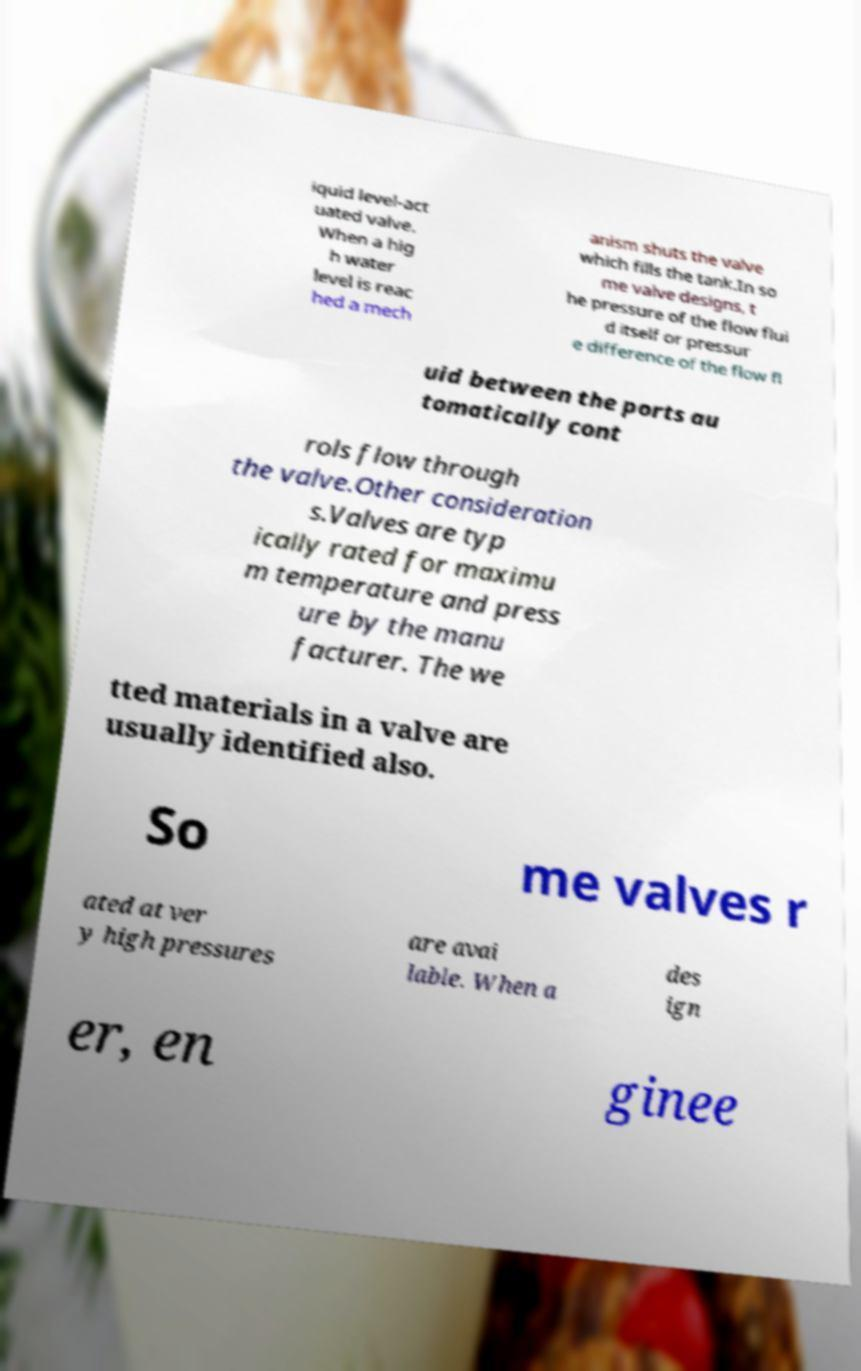Please identify and transcribe the text found in this image. iquid level-act uated valve. When a hig h water level is reac hed a mech anism shuts the valve which fills the tank.In so me valve designs, t he pressure of the flow flui d itself or pressur e difference of the flow fl uid between the ports au tomatically cont rols flow through the valve.Other consideration s.Valves are typ ically rated for maximu m temperature and press ure by the manu facturer. The we tted materials in a valve are usually identified also. So me valves r ated at ver y high pressures are avai lable. When a des ign er, en ginee 